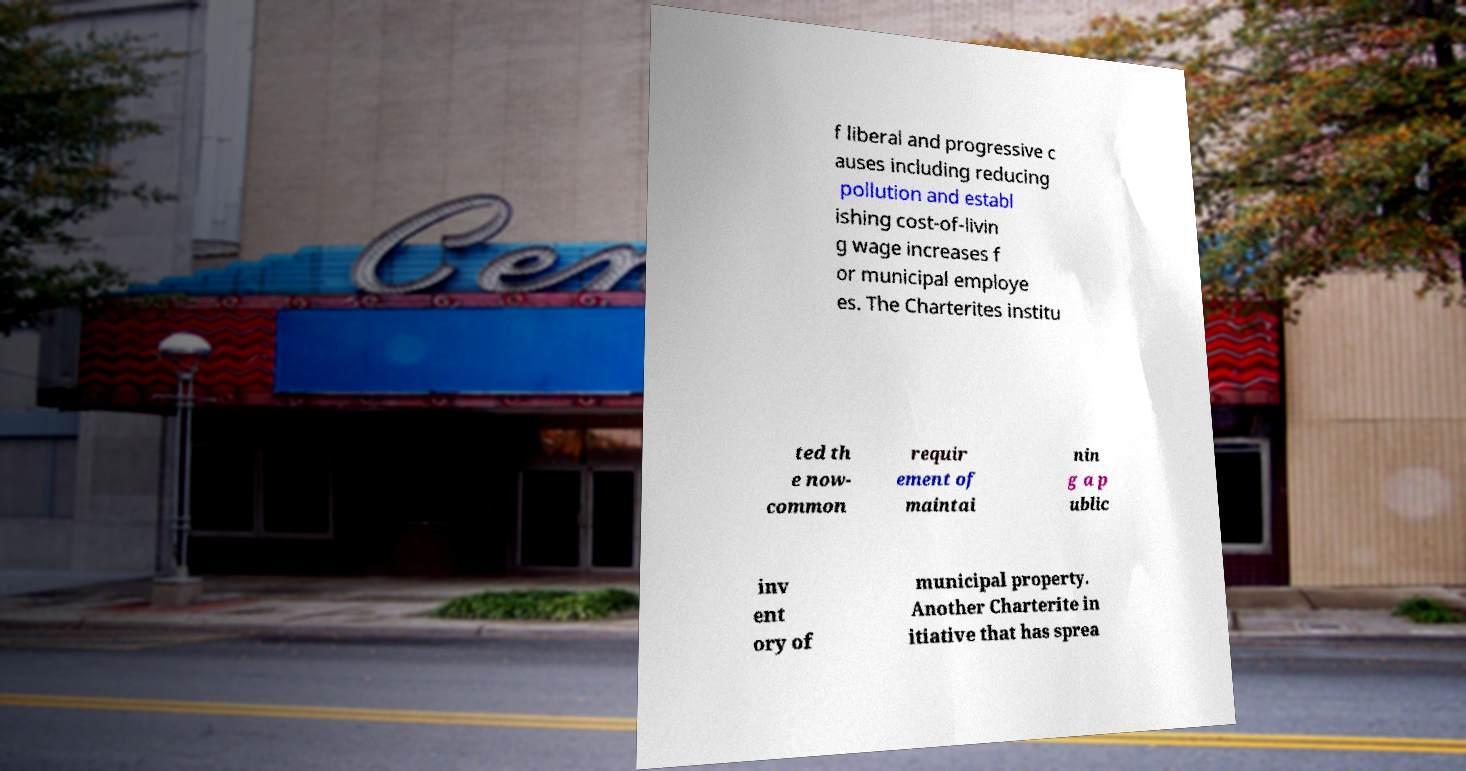There's text embedded in this image that I need extracted. Can you transcribe it verbatim? f liberal and progressive c auses including reducing pollution and establ ishing cost-of-livin g wage increases f or municipal employe es. The Charterites institu ted th e now- common requir ement of maintai nin g a p ublic inv ent ory of municipal property. Another Charterite in itiative that has sprea 